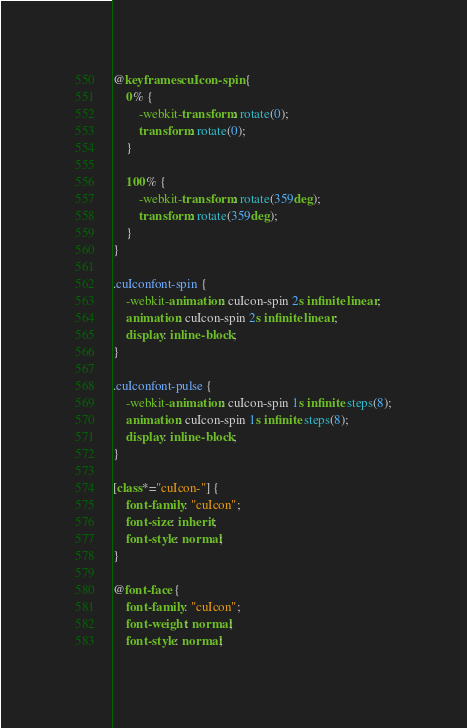<code> <loc_0><loc_0><loc_500><loc_500><_CSS_>@keyframes cuIcon-spin {
	0% {
		-webkit-transform: rotate(0);
		transform: rotate(0);
	}

	100% {
		-webkit-transform: rotate(359deg);
		transform: rotate(359deg);
	}
}

.cuIconfont-spin {
	-webkit-animation: cuIcon-spin 2s infinite linear;
	animation: cuIcon-spin 2s infinite linear;
	display: inline-block;
}

.cuIconfont-pulse {
	-webkit-animation: cuIcon-spin 1s infinite steps(8);
	animation: cuIcon-spin 1s infinite steps(8);
	display: inline-block;
}

[class*="cuIcon-"] {
	font-family: "cuIcon";
	font-size: inherit;
	font-style: normal;
}

@font-face {
	font-family: "cuIcon";
	font-weight: normal;
	font-style: normal;</code> 